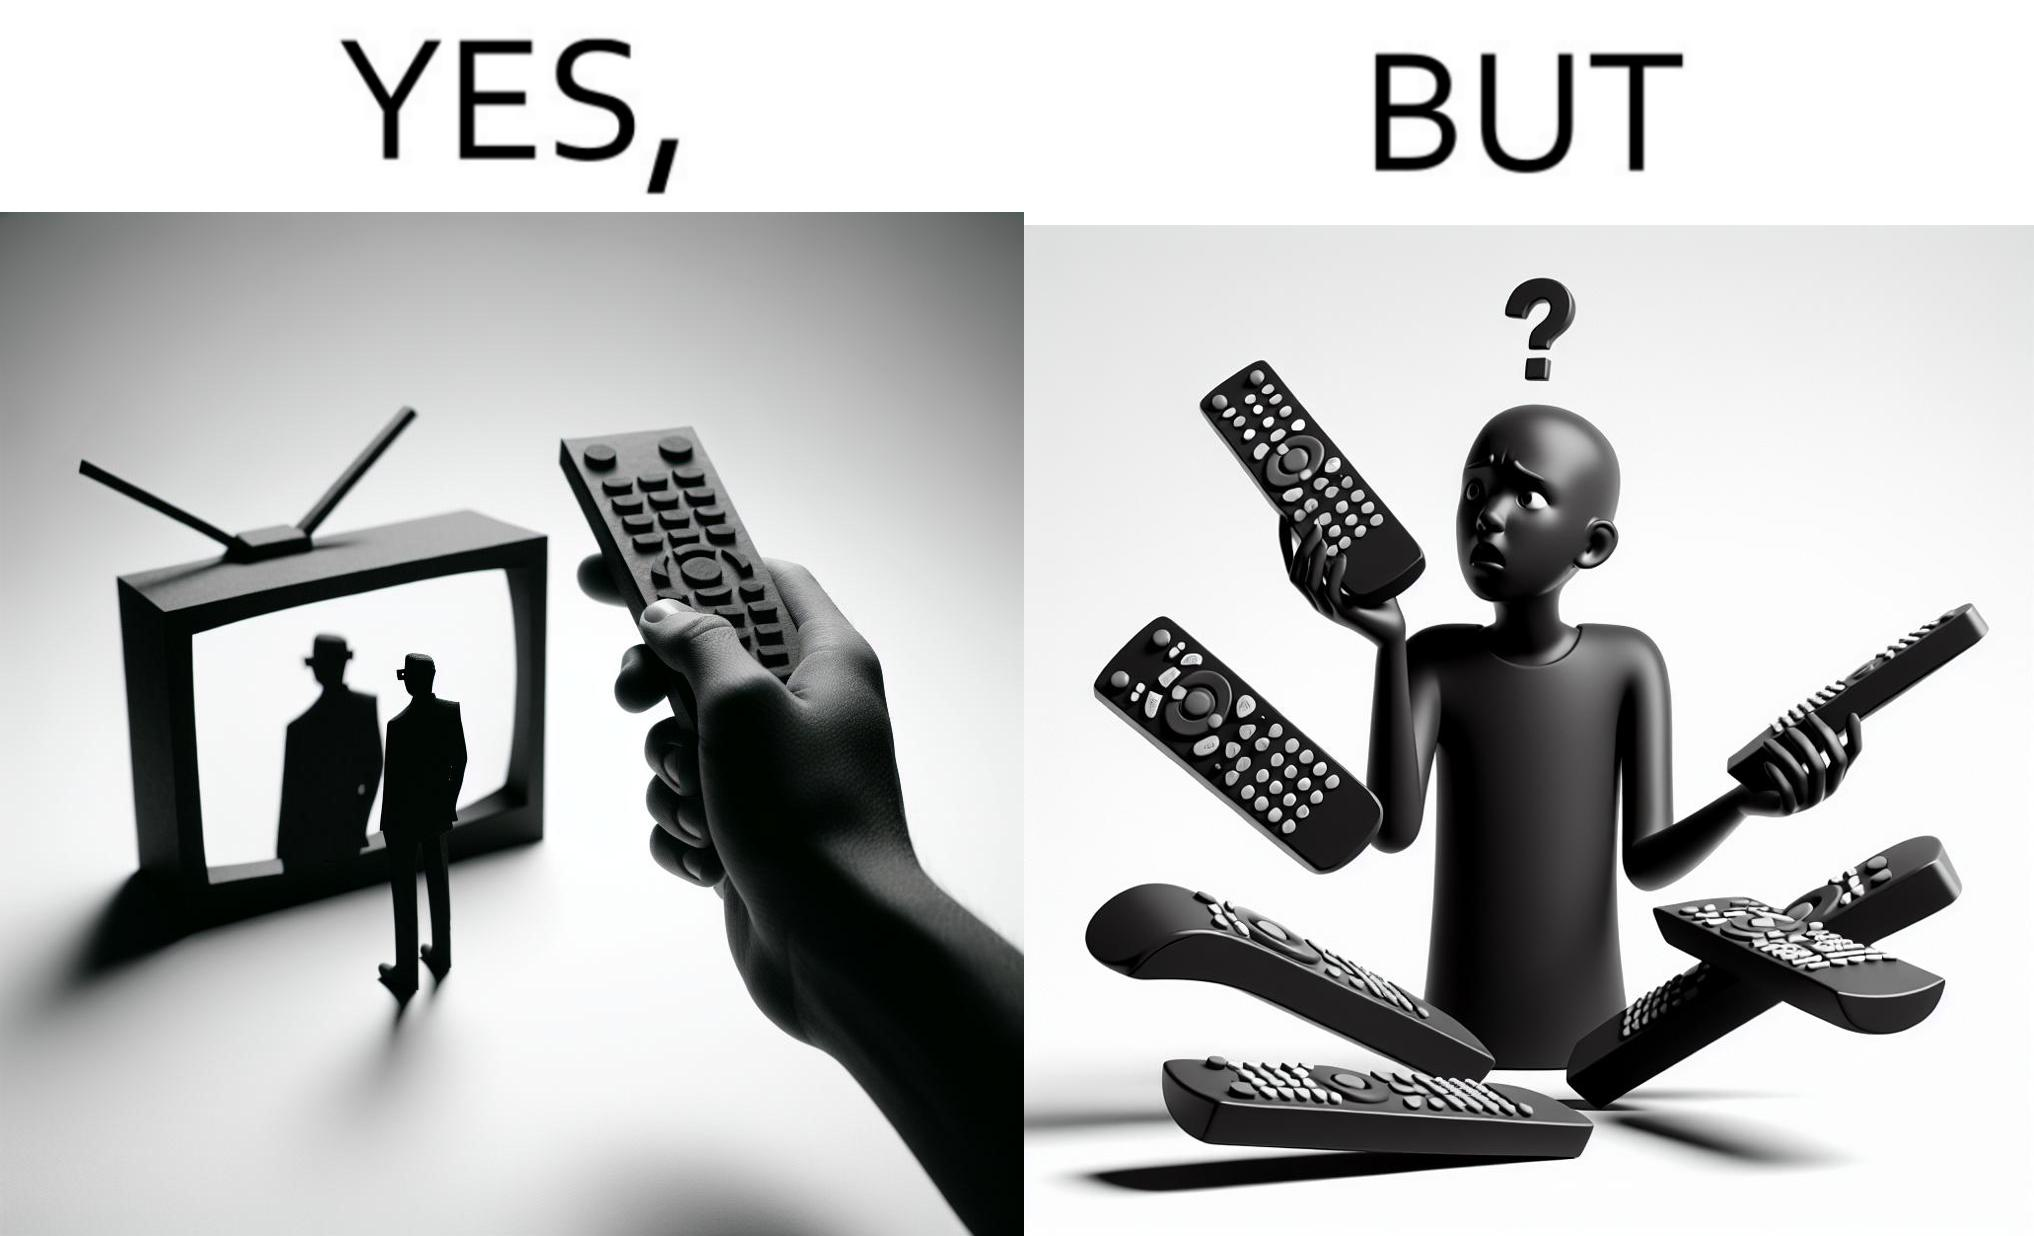Describe the contrast between the left and right parts of this image. In the left part of the image: It is a remote being used to operate a TV In the right part of the image: It is an user confused between multiple remotes 